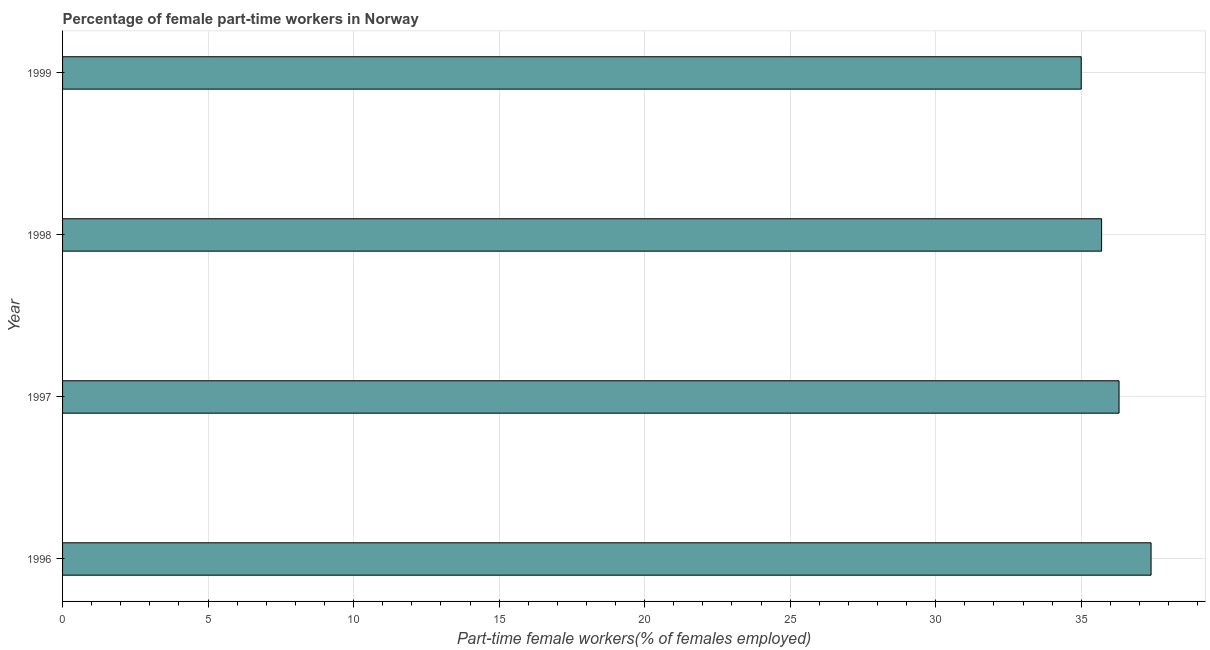Does the graph contain any zero values?
Make the answer very short. No. Does the graph contain grids?
Provide a succinct answer. Yes. What is the title of the graph?
Your answer should be compact. Percentage of female part-time workers in Norway. What is the label or title of the X-axis?
Provide a succinct answer. Part-time female workers(% of females employed). What is the percentage of part-time female workers in 1997?
Make the answer very short. 36.3. Across all years, what is the maximum percentage of part-time female workers?
Give a very brief answer. 37.4. In which year was the percentage of part-time female workers maximum?
Your answer should be compact. 1996. In which year was the percentage of part-time female workers minimum?
Make the answer very short. 1999. What is the sum of the percentage of part-time female workers?
Make the answer very short. 144.4. What is the difference between the percentage of part-time female workers in 1997 and 1998?
Provide a short and direct response. 0.6. What is the average percentage of part-time female workers per year?
Your response must be concise. 36.1. Do a majority of the years between 1997 and 1996 (inclusive) have percentage of part-time female workers greater than 29 %?
Provide a short and direct response. No. What is the ratio of the percentage of part-time female workers in 1996 to that in 1999?
Your answer should be compact. 1.07. What is the difference between the highest and the second highest percentage of part-time female workers?
Provide a short and direct response. 1.1. What is the difference between the highest and the lowest percentage of part-time female workers?
Offer a terse response. 2.4. In how many years, is the percentage of part-time female workers greater than the average percentage of part-time female workers taken over all years?
Provide a short and direct response. 2. How many years are there in the graph?
Offer a very short reply. 4. What is the difference between two consecutive major ticks on the X-axis?
Provide a short and direct response. 5. Are the values on the major ticks of X-axis written in scientific E-notation?
Offer a terse response. No. What is the Part-time female workers(% of females employed) in 1996?
Ensure brevity in your answer.  37.4. What is the Part-time female workers(% of females employed) in 1997?
Provide a short and direct response. 36.3. What is the Part-time female workers(% of females employed) in 1998?
Keep it short and to the point. 35.7. What is the difference between the Part-time female workers(% of females employed) in 1996 and 1997?
Provide a succinct answer. 1.1. What is the difference between the Part-time female workers(% of females employed) in 1996 and 1998?
Your answer should be very brief. 1.7. What is the difference between the Part-time female workers(% of females employed) in 1996 and 1999?
Your answer should be very brief. 2.4. What is the difference between the Part-time female workers(% of females employed) in 1998 and 1999?
Make the answer very short. 0.7. What is the ratio of the Part-time female workers(% of females employed) in 1996 to that in 1997?
Your answer should be very brief. 1.03. What is the ratio of the Part-time female workers(% of females employed) in 1996 to that in 1998?
Make the answer very short. 1.05. What is the ratio of the Part-time female workers(% of females employed) in 1996 to that in 1999?
Offer a very short reply. 1.07. What is the ratio of the Part-time female workers(% of females employed) in 1997 to that in 1999?
Your answer should be very brief. 1.04. What is the ratio of the Part-time female workers(% of females employed) in 1998 to that in 1999?
Give a very brief answer. 1.02. 